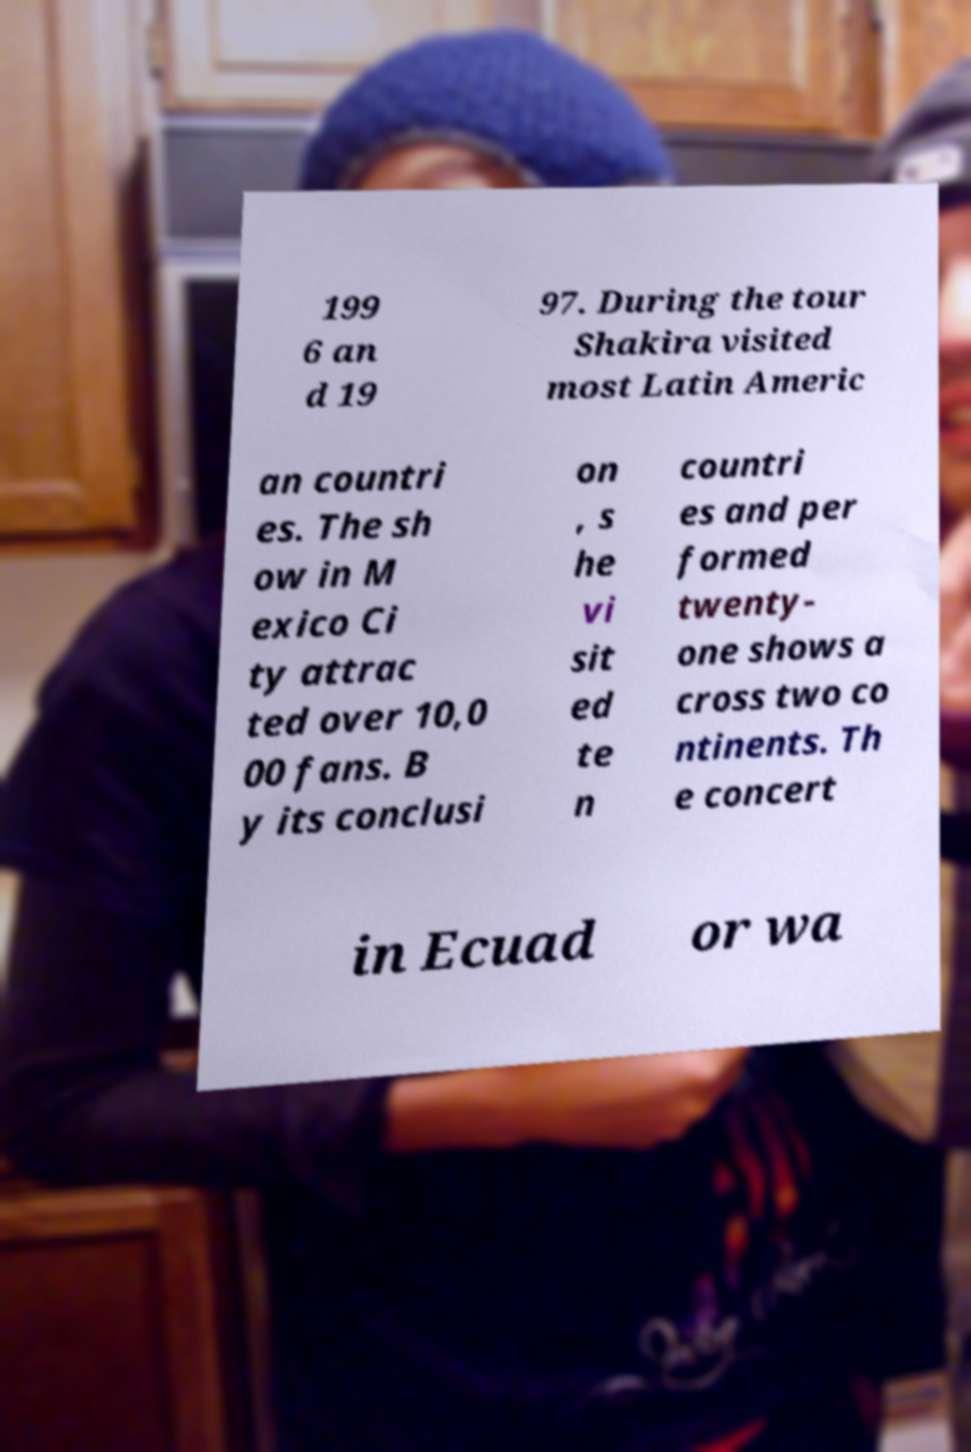I need the written content from this picture converted into text. Can you do that? 199 6 an d 19 97. During the tour Shakira visited most Latin Americ an countri es. The sh ow in M exico Ci ty attrac ted over 10,0 00 fans. B y its conclusi on , s he vi sit ed te n countri es and per formed twenty- one shows a cross two co ntinents. Th e concert in Ecuad or wa 